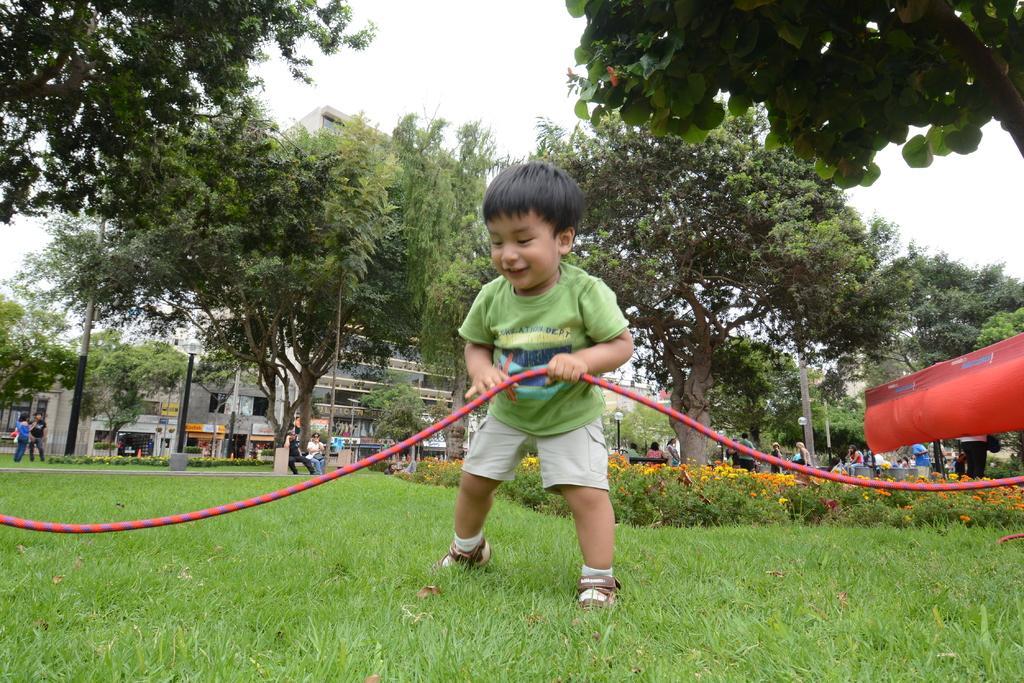Please provide a concise description of this image. In this image I can see a boy in green t shirt holding a rope. In the background I can see number of people, few of them sitting, standing. I can also see number of trees, a building and plants. 